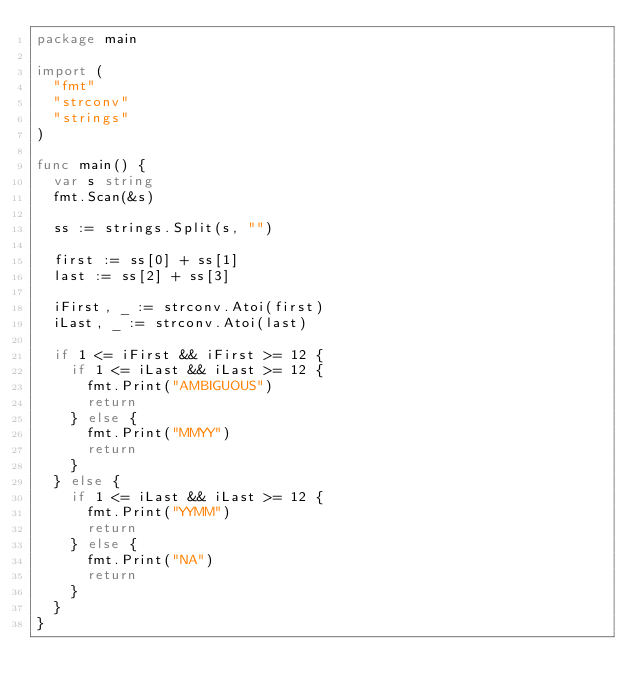<code> <loc_0><loc_0><loc_500><loc_500><_Go_>package main

import (
	"fmt"
	"strconv"
	"strings"
)

func main() {
	var s string
	fmt.Scan(&s)

	ss := strings.Split(s, "")

	first := ss[0] + ss[1]
	last := ss[2] + ss[3]

	iFirst, _ := strconv.Atoi(first)
	iLast, _ := strconv.Atoi(last)

	if 1 <= iFirst && iFirst >= 12 {
		if 1 <= iLast && iLast >= 12 {
			fmt.Print("AMBIGUOUS")
			return
		} else {
			fmt.Print("MMYY")
			return
		}
	} else {
		if 1 <= iLast && iLast >= 12 {
			fmt.Print("YYMM")
			return
		} else {
			fmt.Print("NA")
			return
		}
	}
}
</code> 